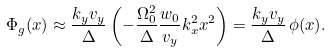<formula> <loc_0><loc_0><loc_500><loc_500>\Phi _ { g } ( x ) \approx \frac { k _ { y } v _ { y } } { \Delta } \left ( - \frac { \Omega _ { 0 } ^ { 2 } } { \Delta } \frac { w _ { 0 } } { v _ { y } } k _ { x } ^ { 2 } x ^ { 2 } \right ) = \frac { k _ { y } v _ { y } } { \Delta } \, \phi ( x ) .</formula> 